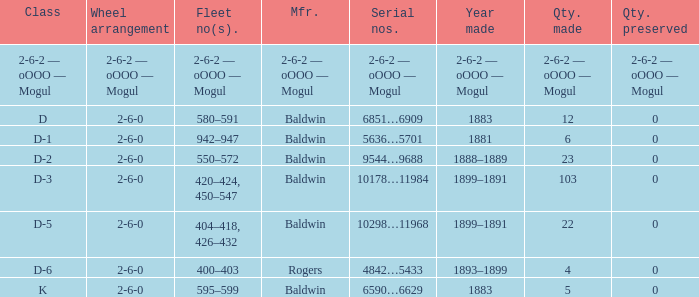What is the year made when the manufacturer is 2-6-2 — oooo — mogul? 2-6-2 — oOOO — Mogul. 